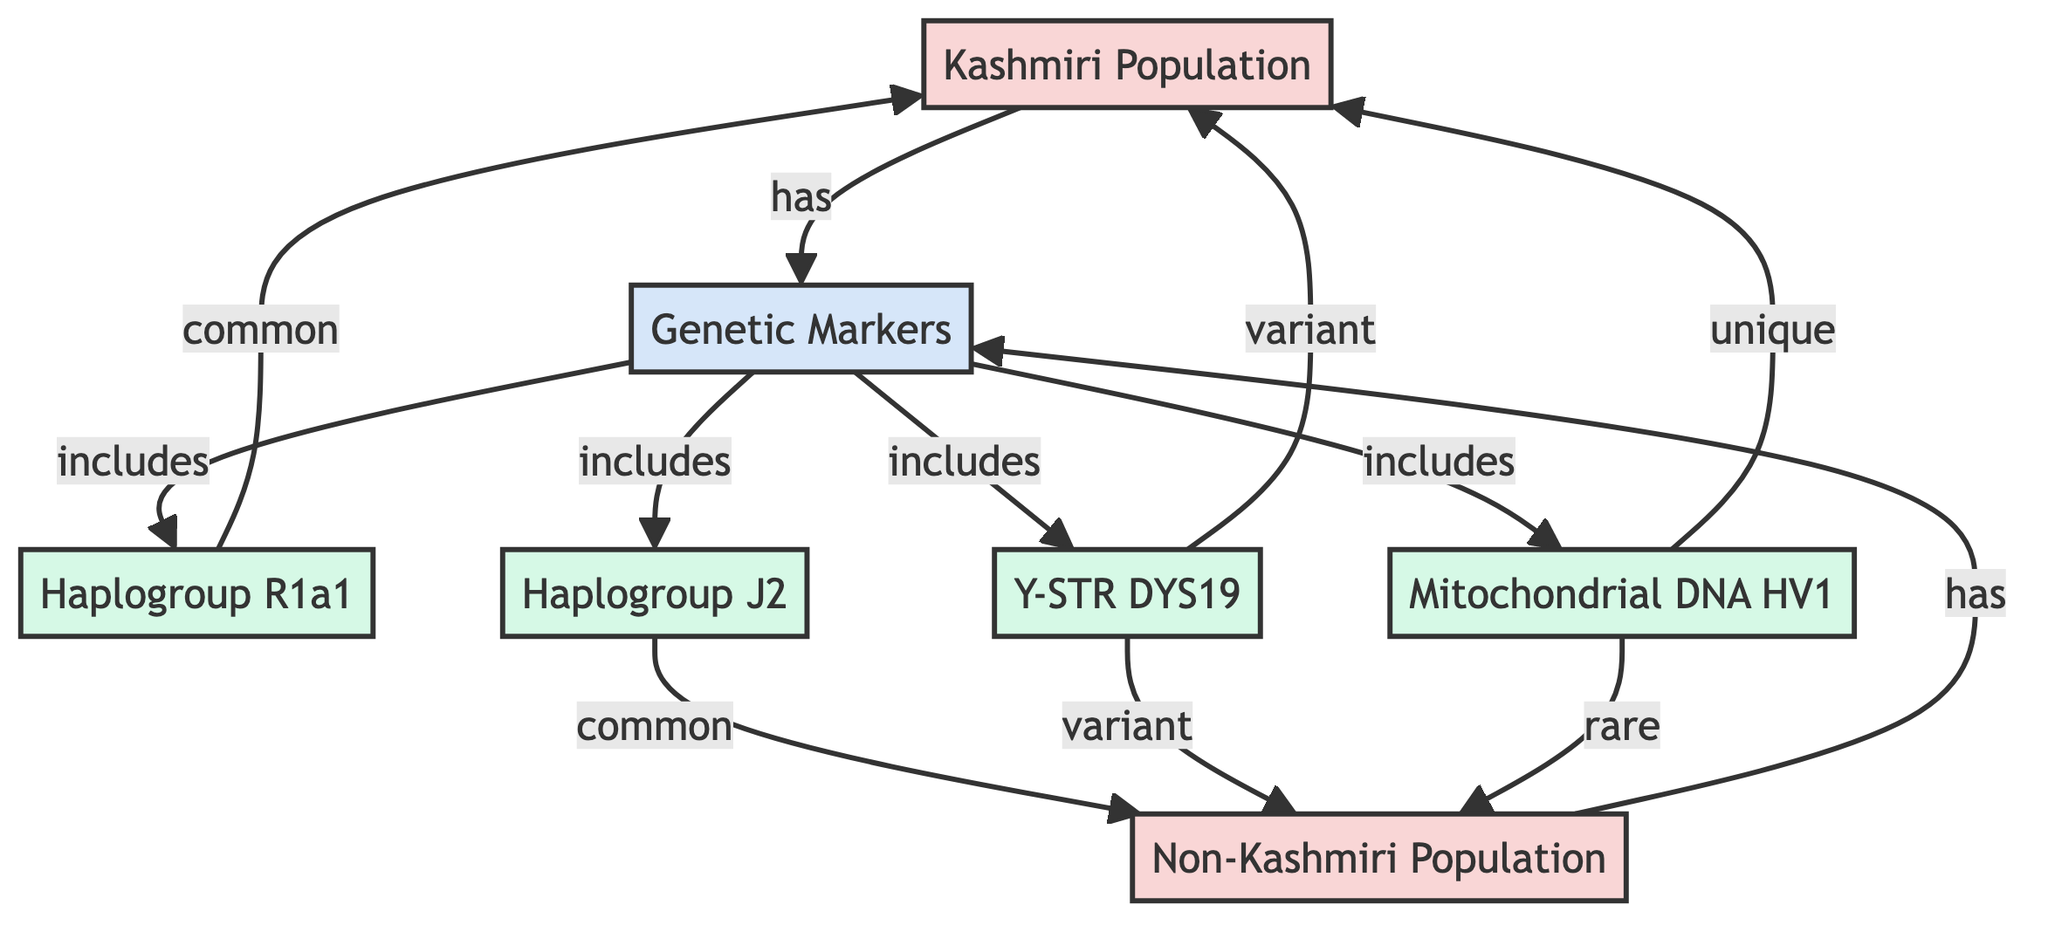What are the two main populations represented in the diagram? The diagram has two main populations represented as nodes: "Kashmiri Population" and "Non-Kashmiri Population". This is observed directly from the population nodes labeled in the diagram.
Answer: Kashmiri Population, Non-Kashmiri Population How many genetic markers are included in the analysis? The diagram shows a category labeled "Genetic Markers" that includes four specific markers: Haplogroup R1a1, Haplogroup J2, Y-STR DYS19, and Mitochondrial DNA HV1. Counting these nodes gives a total of four genetic markers.
Answer: 4 Which genetic marker is common to the Kashmiri population? The diagram indicates that "Haplogroup R1a1" is classified as common specifically to the "Kashmiri Population", as shown in the directed edge connecting them in the diagram.
Answer: Haplogroup R1a1 What unique genetic marker is found in the Kashmiri population? According to the diagram, the genetic marker "Mitochondrial DNA HV1" is unique to the Kashmiri population, as indicated by the label and the relationship shown.
Answer: Mitochondrial DNA HV1 Which genetic marker is rare in the Non-Kashmiri population? The diagram specifies that "Mitochondrial DNA HV1" is categorized as rare in the "Non-Kashmiri Population", supported by the edge relationship illustrated in the diagram.
Answer: Mitochondrial DNA HV1 How do the genetic markers Y-STR DYS19 differ between the two populations? The diagram indicates that Y-STR DYS19 has a variant status for both the Kashmiri and Non-Kashmiri populations, suggesting it differs from common or unique markers. This means it is not categorized as strictly belonging to one population or the other.
Answer: Variant What is the relationship between Haplogroup J2 and the Non-Kashmiri population? The diagram shows an edge from "Haplogroup J2" indicating it is common to the "Non-Kashmiri Population", representing a direct relationship. Therefore, it is clearly indicated as shared between these two entities in the diagram.
Answer: Common Are there any genetic markers that are common to both populations? Yes, the diagram illustrates that "Haplogroup R1a1" is common to the Kashmiri population and "Haplogroup J2" is common to the Non-Kashmiri population, suggesting that these markers are not shared between both populations. Thus, it answers a key aspect of the genetic analysis portrayed in the diagram.
Answer: No 